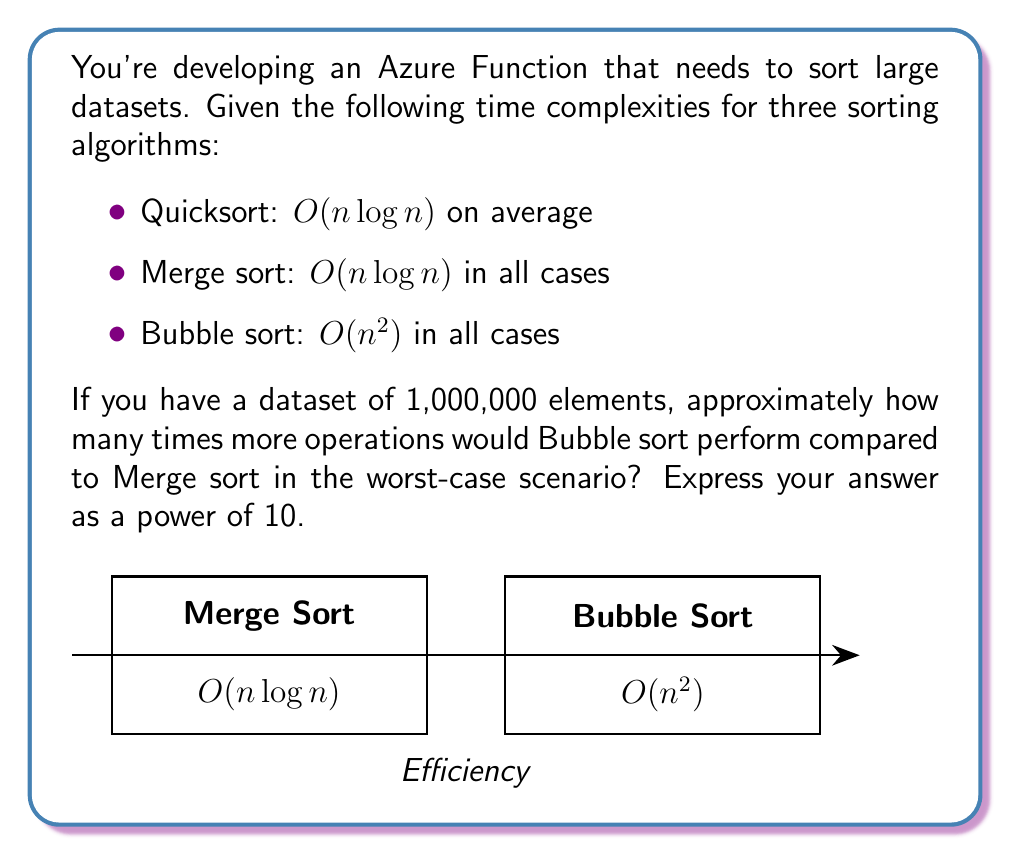Solve this math problem. Let's approach this step-by-step:

1) First, let's calculate the approximate number of operations for each algorithm:

   For Merge sort: $O(n \log n)$
   $n \log n = 1,000,000 \cdot \log(1,000,000) \approx 1,000,000 \cdot 20 = 20,000,000$

   For Bubble sort: $O(n^2)$
   $n^2 = 1,000,000^2 = 1,000,000,000,000$

2) Now, let's calculate how many times more operations Bubble sort performs:

   $\frac{\text{Bubble sort operations}}{\text{Merge sort operations}} = \frac{1,000,000,000,000}{20,000,000} = 50,000$

3) We need to express this as a power of 10. We can do this by taking the logarithm base 10:

   $\log_{10}(50,000) \approx 4.7$

4) Rounding to the nearest whole number, we get 5.

Therefore, Bubble sort performs approximately $10^5$ times more operations than Merge sort for this dataset size.
Answer: $10^5$ 